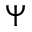Convert formula to latex. <formula><loc_0><loc_0><loc_500><loc_500>\Psi</formula> 